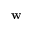<formula> <loc_0><loc_0><loc_500><loc_500>w</formula> 